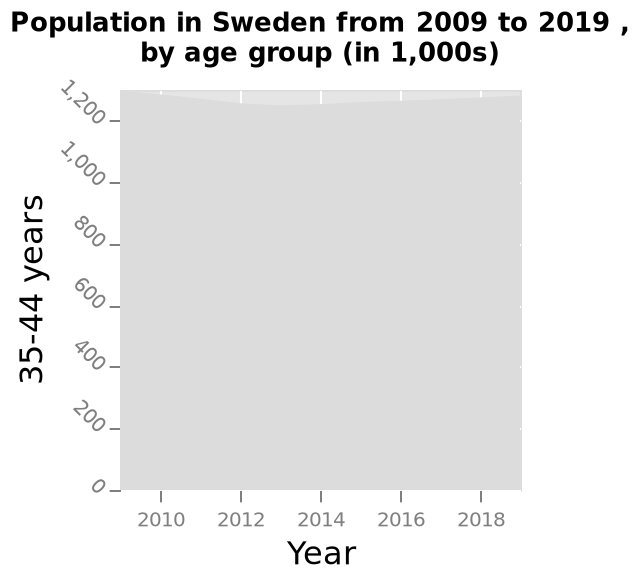<image>
Why is the graph not showing any data? The graph has not loaded yet, hence no data is being displayed. What is the title of the area chart? The title of the area chart is "Population in Sweden from 2009 to 2019, by age group (in 1,000s)". What is the y-axis measuring on the area chart?  The y-axis measures the population in Sweden from 2009 to 2019, by age group (in 1,000s). 